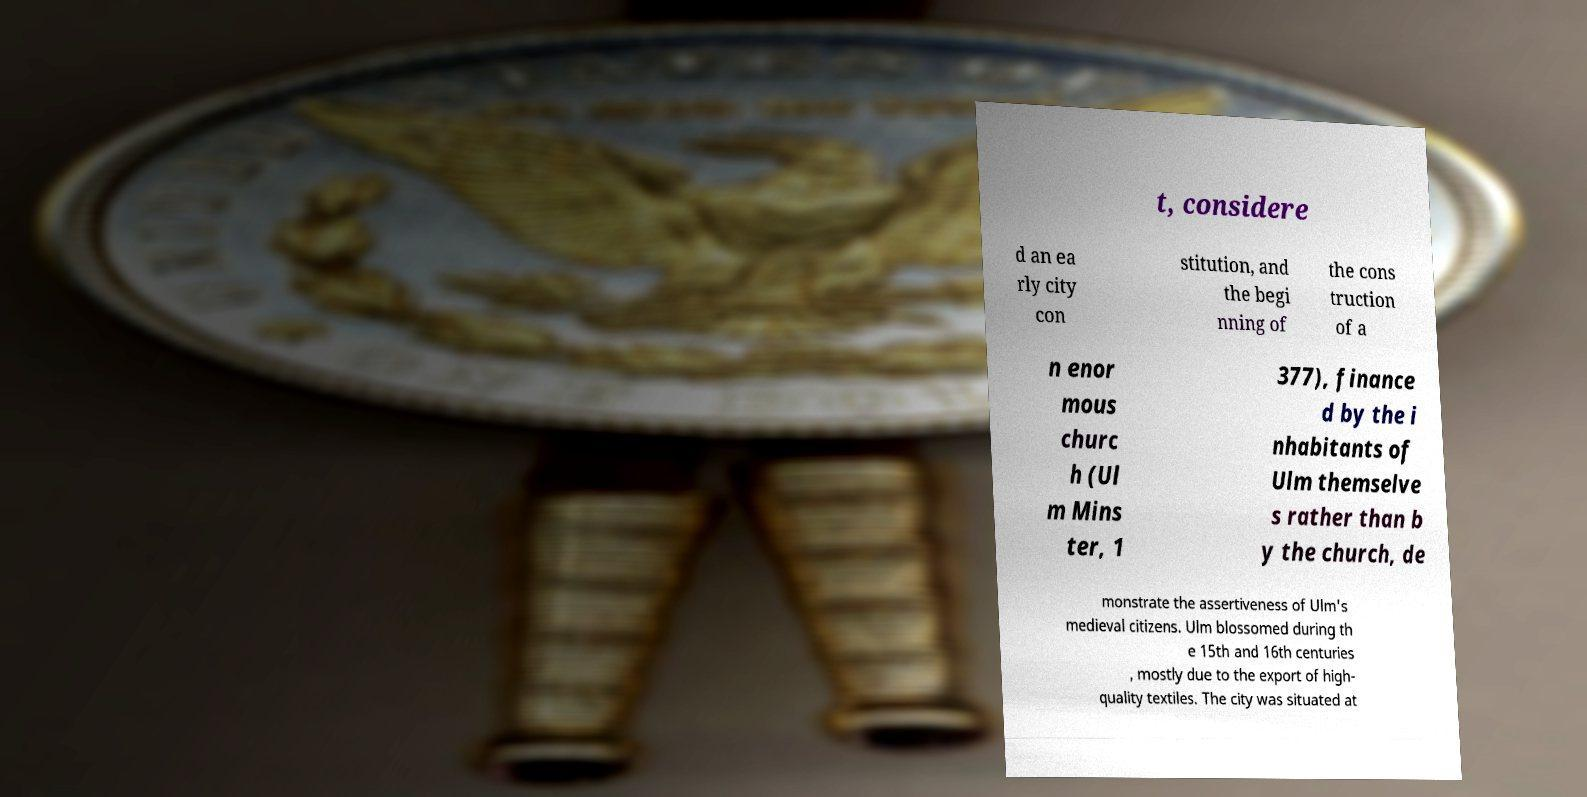For documentation purposes, I need the text within this image transcribed. Could you provide that? t, considere d an ea rly city con stitution, and the begi nning of the cons truction of a n enor mous churc h (Ul m Mins ter, 1 377), finance d by the i nhabitants of Ulm themselve s rather than b y the church, de monstrate the assertiveness of Ulm's medieval citizens. Ulm blossomed during th e 15th and 16th centuries , mostly due to the export of high- quality textiles. The city was situated at 